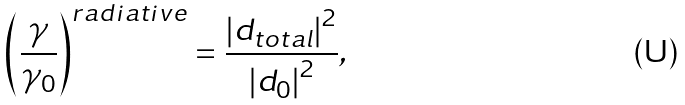<formula> <loc_0><loc_0><loc_500><loc_500>\left ( \frac { \gamma } { \gamma _ { 0 } } \right ) ^ { r a d i a t i v e } = \frac { \left | d _ { t o t a l } \right | ^ { 2 } } { \left | d _ { 0 } \right | ^ { 2 } } ,</formula> 